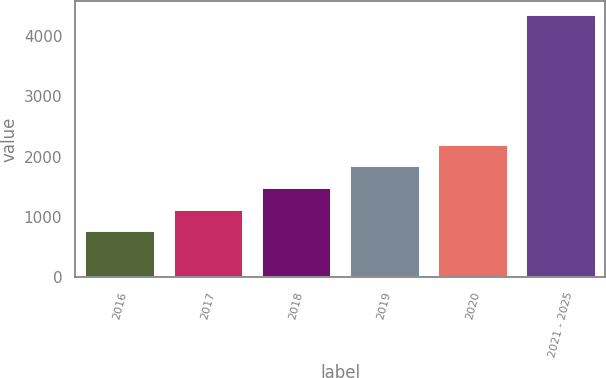Convert chart. <chart><loc_0><loc_0><loc_500><loc_500><bar_chart><fcel>2016<fcel>2017<fcel>2018<fcel>2019<fcel>2020<fcel>2021 - 2025<nl><fcel>782<fcel>1140.3<fcel>1498.6<fcel>1856.9<fcel>2215.2<fcel>4365<nl></chart> 